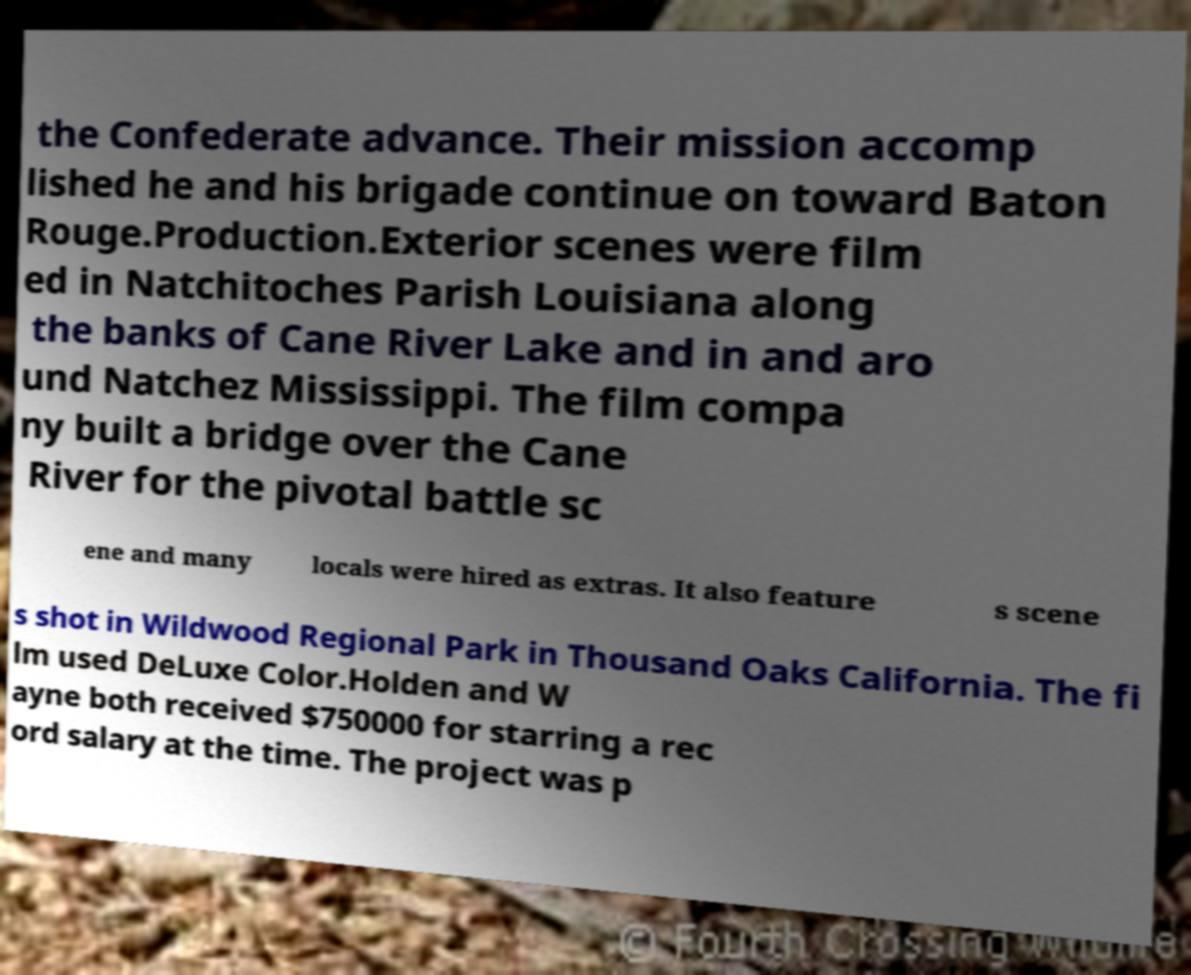There's text embedded in this image that I need extracted. Can you transcribe it verbatim? the Confederate advance. Their mission accomp lished he and his brigade continue on toward Baton Rouge.Production.Exterior scenes were film ed in Natchitoches Parish Louisiana along the banks of Cane River Lake and in and aro und Natchez Mississippi. The film compa ny built a bridge over the Cane River for the pivotal battle sc ene and many locals were hired as extras. It also feature s scene s shot in Wildwood Regional Park in Thousand Oaks California. The fi lm used DeLuxe Color.Holden and W ayne both received $750000 for starring a rec ord salary at the time. The project was p 